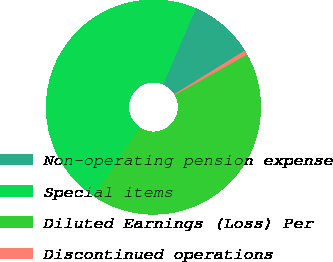Convert chart. <chart><loc_0><loc_0><loc_500><loc_500><pie_chart><fcel>Non-operating pension expense<fcel>Special items<fcel>Diluted Earnings (Loss) Per<fcel>Discontinued operations<nl><fcel>9.74%<fcel>47.08%<fcel>42.53%<fcel>0.65%<nl></chart> 